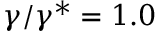<formula> <loc_0><loc_0><loc_500><loc_500>\gamma / \gamma ^ { * } = 1 . 0</formula> 